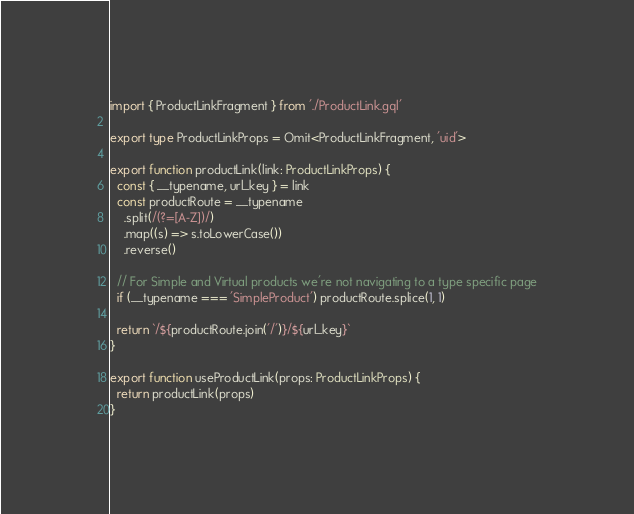<code> <loc_0><loc_0><loc_500><loc_500><_TypeScript_>import { ProductLinkFragment } from './ProductLink.gql'

export type ProductLinkProps = Omit<ProductLinkFragment, 'uid'>

export function productLink(link: ProductLinkProps) {
  const { __typename, url_key } = link
  const productRoute = __typename
    .split(/(?=[A-Z])/)
    .map((s) => s.toLowerCase())
    .reverse()

  // For Simple and Virtual products we're not navigating to a type specific page
  if (__typename === 'SimpleProduct') productRoute.splice(1, 1)

  return `/${productRoute.join('/')}/${url_key}`
}

export function useProductLink(props: ProductLinkProps) {
  return productLink(props)
}
</code> 